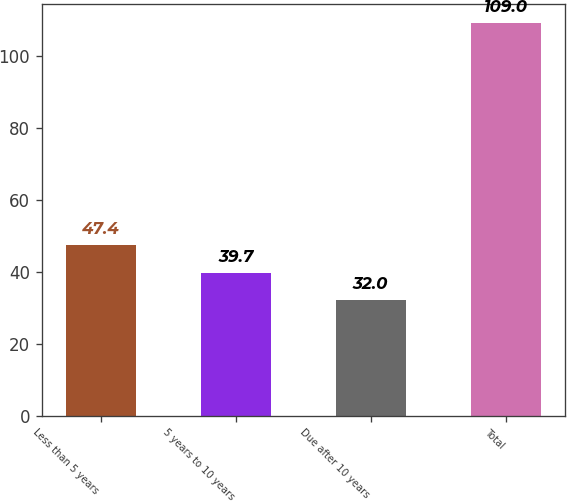<chart> <loc_0><loc_0><loc_500><loc_500><bar_chart><fcel>Less than 5 years<fcel>5 years to 10 years<fcel>Due after 10 years<fcel>Total<nl><fcel>47.4<fcel>39.7<fcel>32<fcel>109<nl></chart> 